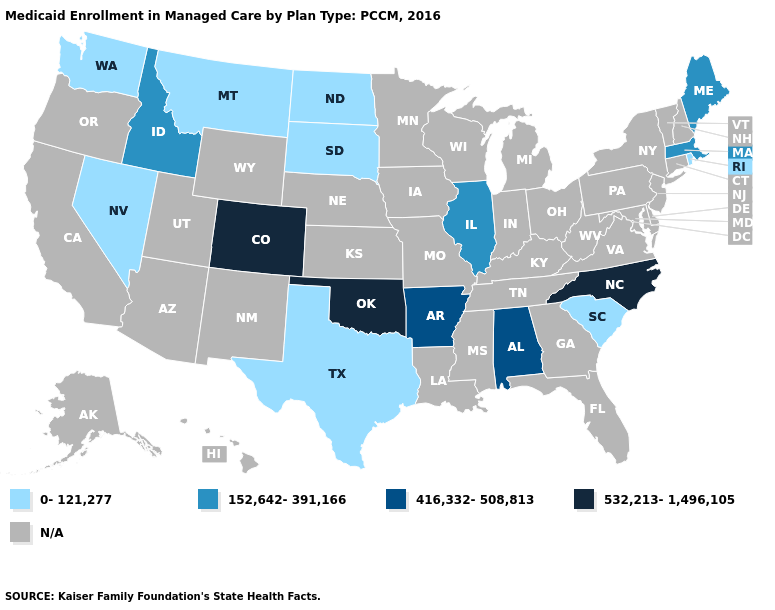Is the legend a continuous bar?
Short answer required. No. Name the states that have a value in the range N/A?
Be succinct. Alaska, Arizona, California, Connecticut, Delaware, Florida, Georgia, Hawaii, Indiana, Iowa, Kansas, Kentucky, Louisiana, Maryland, Michigan, Minnesota, Mississippi, Missouri, Nebraska, New Hampshire, New Jersey, New Mexico, New York, Ohio, Oregon, Pennsylvania, Tennessee, Utah, Vermont, Virginia, West Virginia, Wisconsin, Wyoming. What is the value of Kansas?
Give a very brief answer. N/A. Does the map have missing data?
Write a very short answer. Yes. What is the value of Oregon?
Write a very short answer. N/A. Does Idaho have the lowest value in the USA?
Answer briefly. No. Name the states that have a value in the range N/A?
Short answer required. Alaska, Arizona, California, Connecticut, Delaware, Florida, Georgia, Hawaii, Indiana, Iowa, Kansas, Kentucky, Louisiana, Maryland, Michigan, Minnesota, Mississippi, Missouri, Nebraska, New Hampshire, New Jersey, New Mexico, New York, Ohio, Oregon, Pennsylvania, Tennessee, Utah, Vermont, Virginia, West Virginia, Wisconsin, Wyoming. How many symbols are there in the legend?
Quick response, please. 5. Name the states that have a value in the range 416,332-508,813?
Give a very brief answer. Alabama, Arkansas. Name the states that have a value in the range 532,213-1,496,105?
Write a very short answer. Colorado, North Carolina, Oklahoma. Name the states that have a value in the range 0-121,277?
Quick response, please. Montana, Nevada, North Dakota, Rhode Island, South Carolina, South Dakota, Texas, Washington. Which states have the lowest value in the South?
Write a very short answer. South Carolina, Texas. What is the value of Oklahoma?
Short answer required. 532,213-1,496,105. What is the value of Georgia?
Give a very brief answer. N/A. 